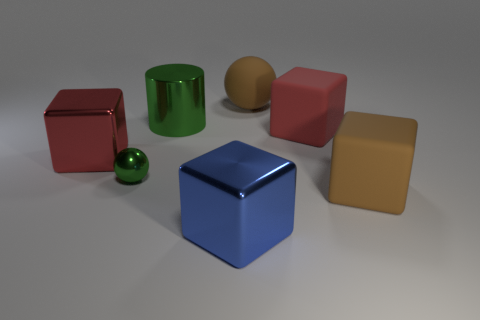Add 1 big red things. How many objects exist? 8 Subtract all cylinders. How many objects are left? 6 Subtract 0 blue cylinders. How many objects are left? 7 Subtract all green cylinders. Subtract all small green metal things. How many objects are left? 5 Add 4 brown spheres. How many brown spheres are left? 5 Add 2 big cyan objects. How many big cyan objects exist? 2 